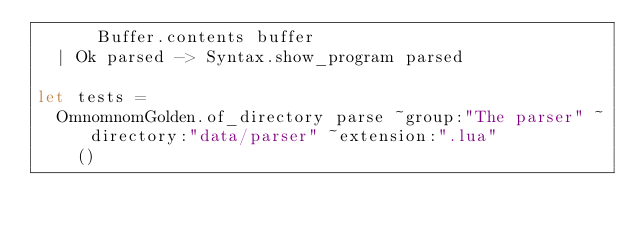<code> <loc_0><loc_0><loc_500><loc_500><_OCaml_>      Buffer.contents buffer
  | Ok parsed -> Syntax.show_program parsed

let tests =
  OmnomnomGolden.of_directory parse ~group:"The parser" ~directory:"data/parser" ~extension:".lua"
    ()
</code> 